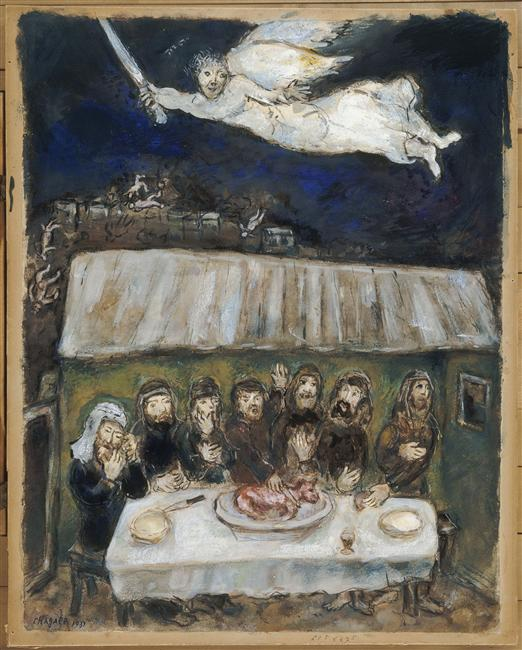Can you describe the main features of this image for me? The image is a surrealistic expression of a gathering. The scene unfolds in a dark setting, illuminated by accents of white and light blue. At the center, a group of people are huddled around a table, their attention drawn to a large piece of meat that rests on it. Hovering above them, an angel-like figure takes flight, a sword clutched in its grasp. The art style leans towards expressionism, with the surreal genre evident in the juxtaposition of ordinary and fantastical elements. The overall mood is one of intrigue and mystery, as the viewer is left to interpret the symbolism within this surrealistic tableau. 